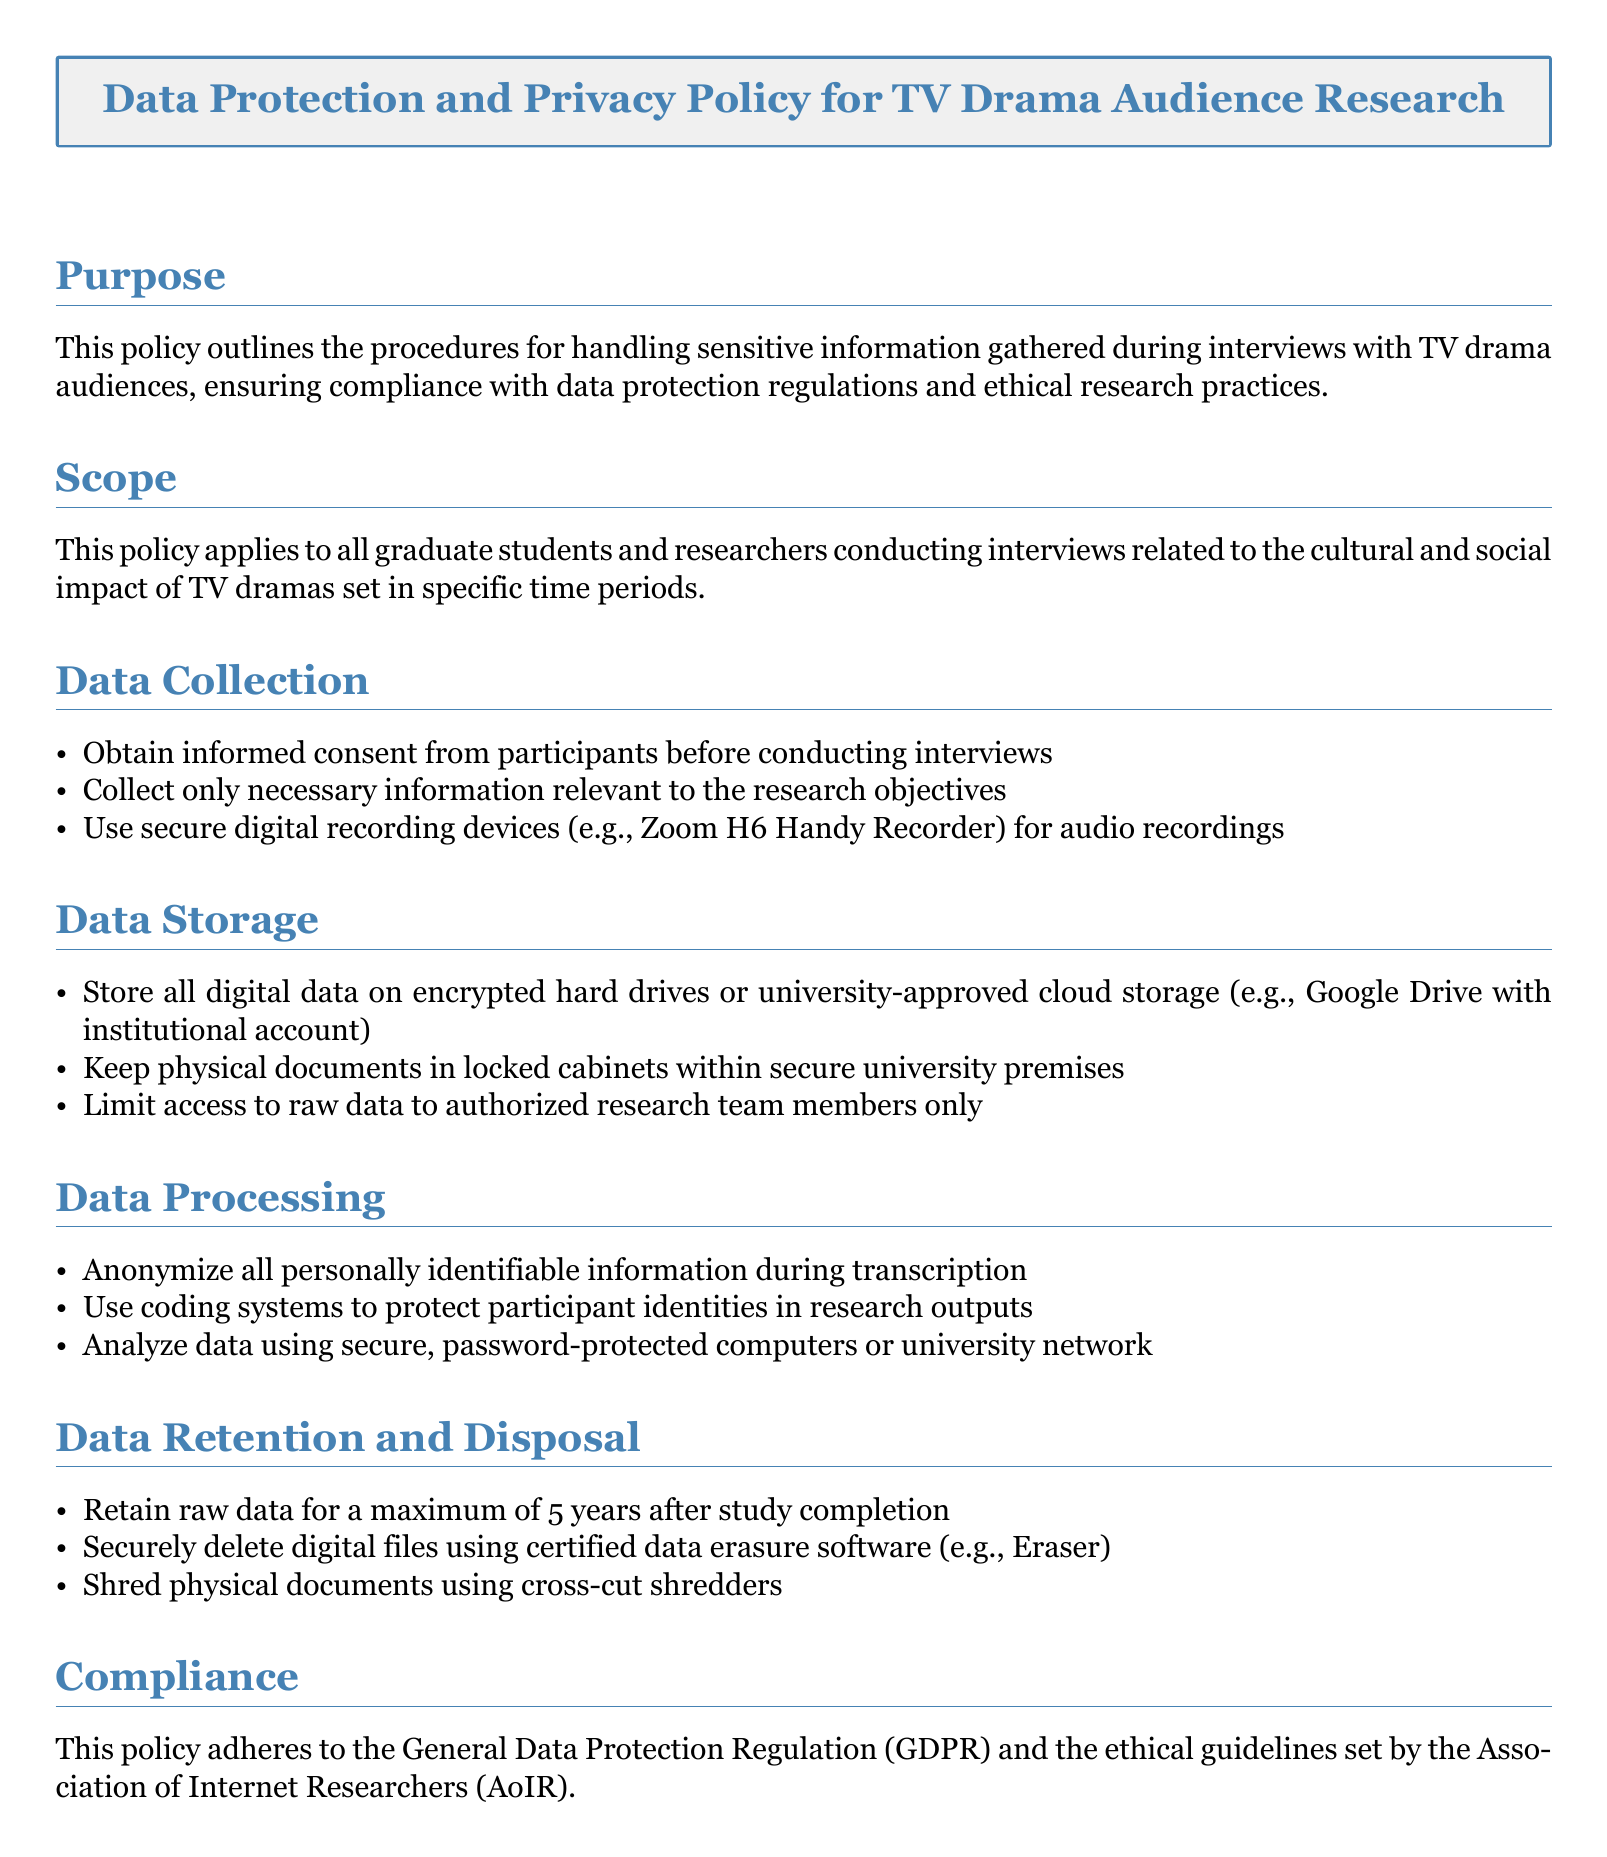What is the purpose of the policy? The purpose is to outline procedures for handling sensitive information gathered during interviews, ensuring compliance with regulations and ethical practices.
Answer: Compliance with regulations and ethical practices Who does this policy apply to? The policy applies to graduate students and researchers conducting interviews about the cultural and social impact of TV dramas.
Answer: Graduate students and researchers What device should be used for audio recordings? The document specifies using secure digital recording devices for audio recordings.
Answer: Zoom H6 Handy Recorder How long should raw data be retained after study completion? The policy states that raw data should be retained for a maximum specified duration after the study is completed.
Answer: 5 years What must be done to protect participant identities during data processing? The document outlines that personally identifiable information must be anonymized during transcription to protect identities.
Answer: Anonymize information What guidelines does this policy adhere to? This policy adheres to the General Data Protection Regulation and the ethical guidelines set by a specific organization.
Answer: GDPR and AoIR Where should physical documents be stored? The policy specifies that physical documents should be kept in locked cabinets within secure premises.
Answer: Locked cabinets What should be done with digital files after their retention period? The document advises that digital files should be securely deleted using specific certified software after the retention period.
Answer: Certified data erasure software Which systems should be used to protect data during analysis? The policy suggests using secure, password-protected computers or the university network for data analysis.
Answer: Password-protected computers or university network 